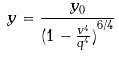<formula> <loc_0><loc_0><loc_500><loc_500>y = \frac { y _ { 0 } } { ( { 1 - \frac { v ^ { 4 } } { q ^ { 4 } } ) } ^ { 6 / 4 } }</formula> 